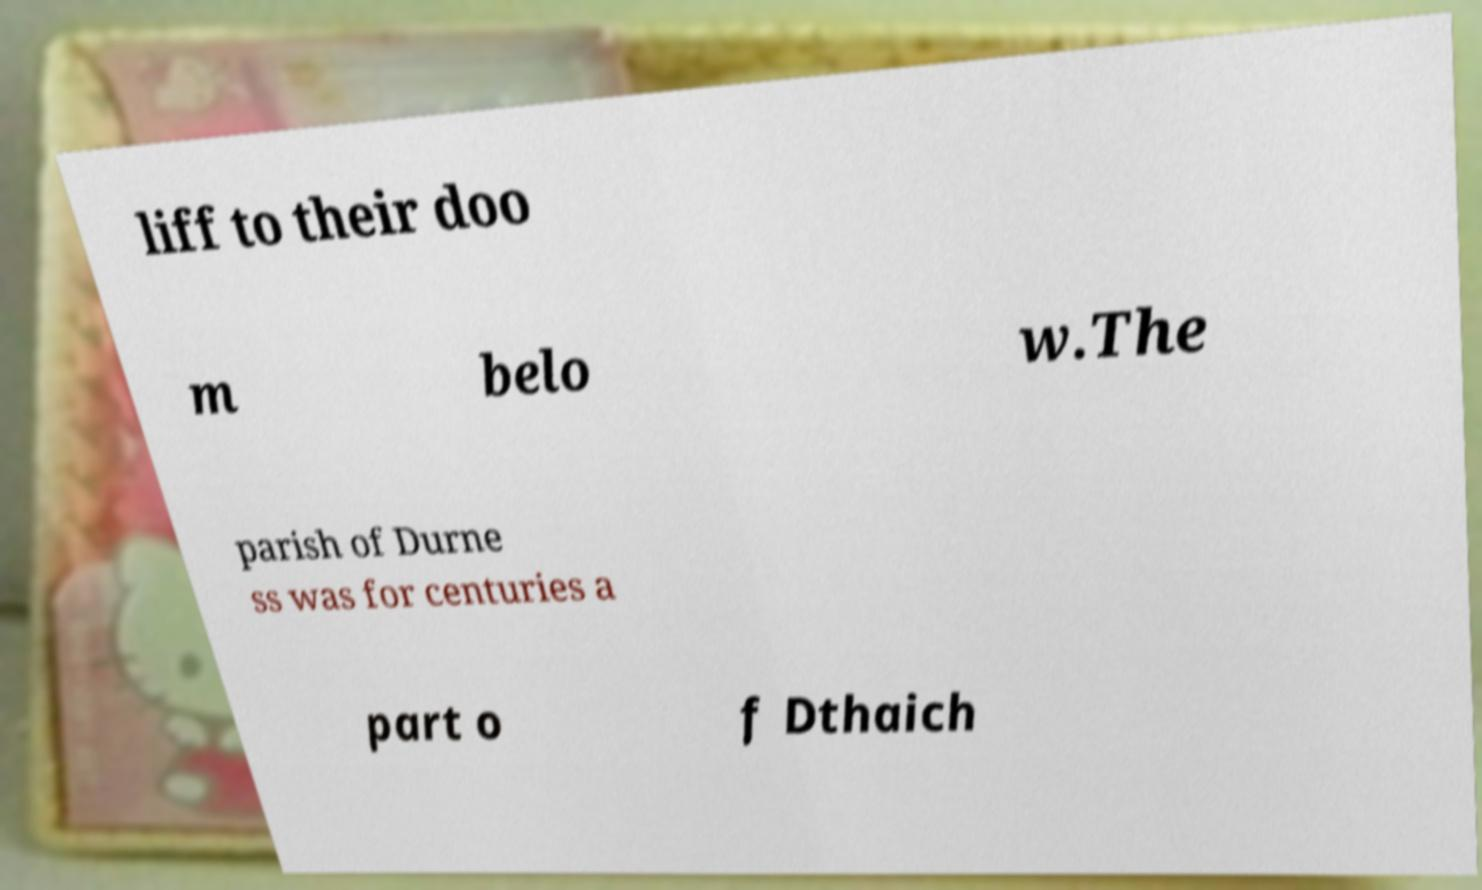Please read and relay the text visible in this image. What does it say? liff to their doo m belo w.The parish of Durne ss was for centuries a part o f Dthaich 